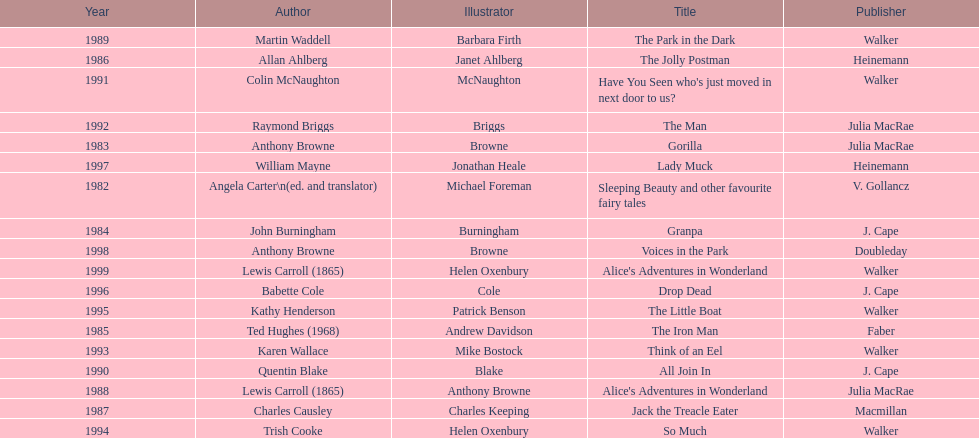Which book won the award a total of 2 times? Alice's Adventures in Wonderland. 